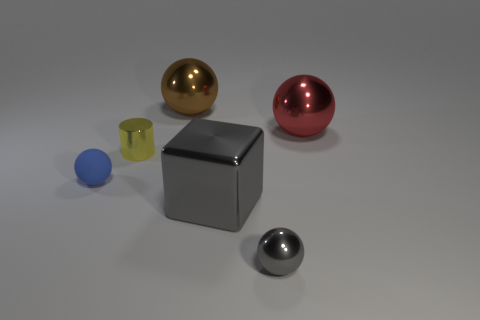Subtract all shiny balls. How many balls are left? 1 Subtract all red spheres. How many spheres are left? 3 Subtract all cyan spheres. Subtract all red blocks. How many spheres are left? 4 Add 1 brown balls. How many objects exist? 7 Subtract all blocks. How many objects are left? 5 Add 5 large shiny objects. How many large shiny objects exist? 8 Subtract 1 yellow cylinders. How many objects are left? 5 Subtract all small yellow metallic objects. Subtract all small balls. How many objects are left? 3 Add 5 small shiny objects. How many small shiny objects are left? 7 